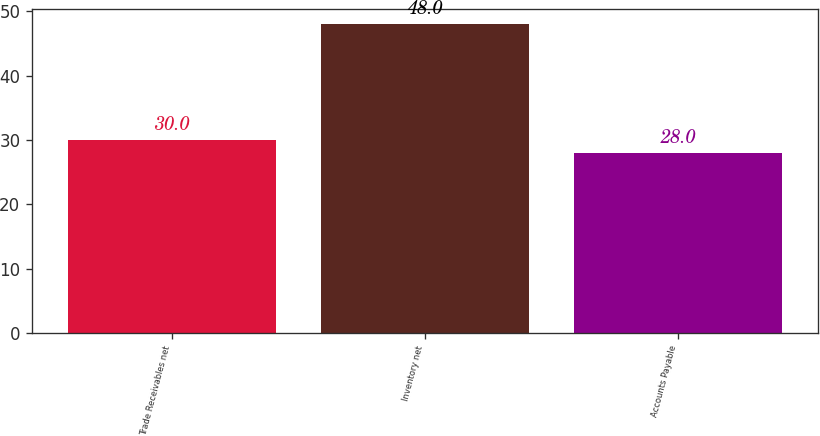Convert chart to OTSL. <chart><loc_0><loc_0><loc_500><loc_500><bar_chart><fcel>Trade Receivables net<fcel>Inventory net<fcel>Accounts Payable<nl><fcel>30<fcel>48<fcel>28<nl></chart> 